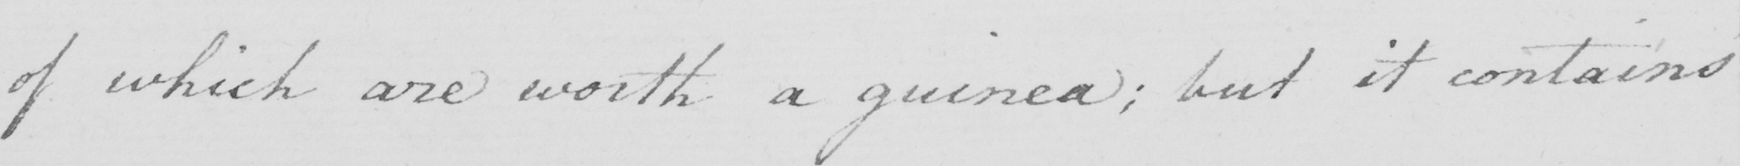Transcribe the text shown in this historical manuscript line. of which are worth a guinea ; but it contains 